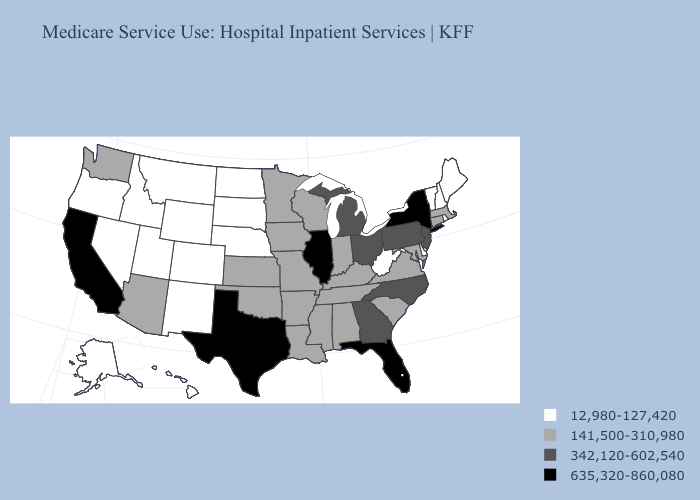Name the states that have a value in the range 141,500-310,980?
Short answer required. Alabama, Arizona, Arkansas, Connecticut, Indiana, Iowa, Kansas, Kentucky, Louisiana, Maryland, Massachusetts, Minnesota, Mississippi, Missouri, Oklahoma, South Carolina, Tennessee, Virginia, Washington, Wisconsin. What is the lowest value in the USA?
Write a very short answer. 12,980-127,420. Does Oklahoma have the highest value in the USA?
Answer briefly. No. Among the states that border Michigan , does Wisconsin have the highest value?
Quick response, please. No. Does Massachusetts have the lowest value in the Northeast?
Answer briefly. No. What is the lowest value in the USA?
Concise answer only. 12,980-127,420. What is the value of Minnesota?
Short answer required. 141,500-310,980. What is the value of Alaska?
Concise answer only. 12,980-127,420. Name the states that have a value in the range 12,980-127,420?
Keep it brief. Alaska, Colorado, Delaware, Hawaii, Idaho, Maine, Montana, Nebraska, Nevada, New Hampshire, New Mexico, North Dakota, Oregon, Rhode Island, South Dakota, Utah, Vermont, West Virginia, Wyoming. Name the states that have a value in the range 635,320-860,080?
Quick response, please. California, Florida, Illinois, New York, Texas. Which states have the lowest value in the MidWest?
Be succinct. Nebraska, North Dakota, South Dakota. What is the value of Hawaii?
Concise answer only. 12,980-127,420. What is the value of West Virginia?
Concise answer only. 12,980-127,420. Which states hav the highest value in the Northeast?
Keep it brief. New York. 